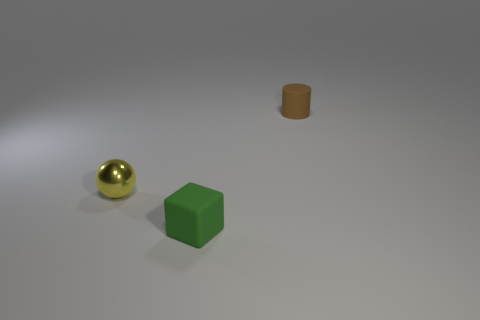Add 2 gray metallic spheres. How many objects exist? 5 Subtract all cylinders. How many objects are left? 2 Add 2 tiny yellow objects. How many tiny yellow objects exist? 3 Subtract 0 purple balls. How many objects are left? 3 Subtract all green things. Subtract all brown rubber cylinders. How many objects are left? 1 Add 1 tiny green rubber cubes. How many tiny green rubber cubes are left? 2 